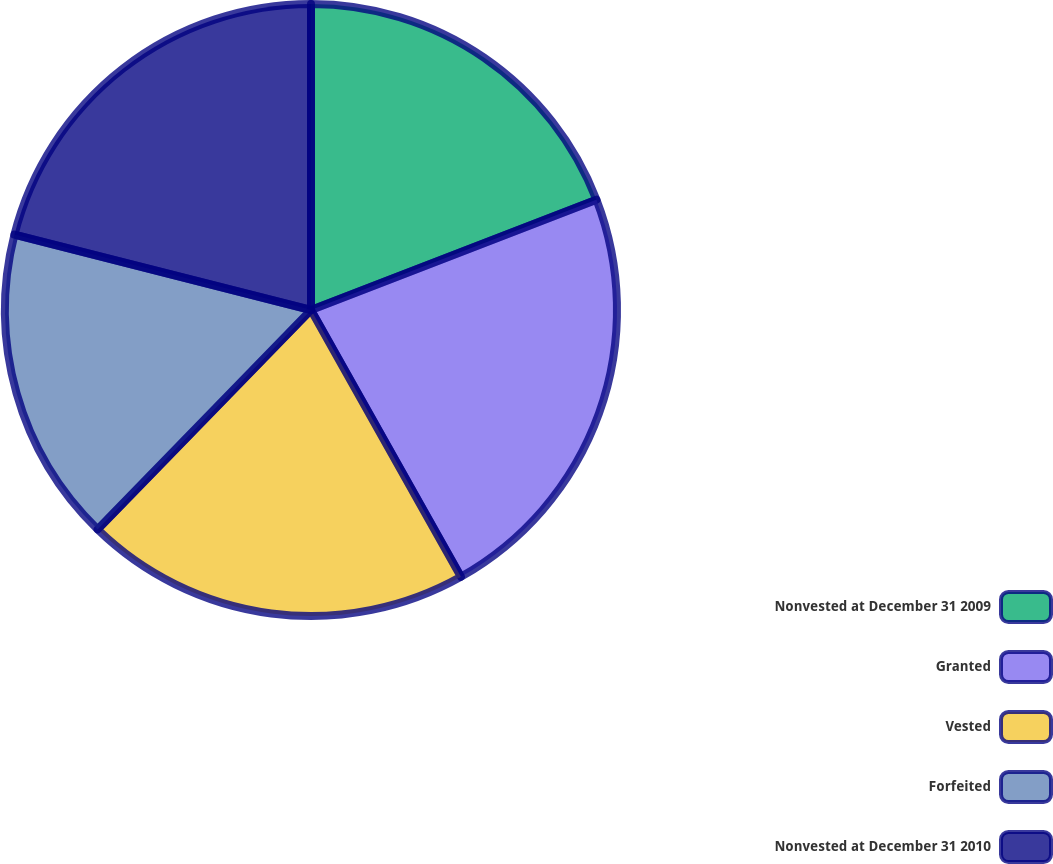Convert chart to OTSL. <chart><loc_0><loc_0><loc_500><loc_500><pie_chart><fcel>Nonvested at December 31 2009<fcel>Granted<fcel>Vested<fcel>Forfeited<fcel>Nonvested at December 31 2010<nl><fcel>19.13%<fcel>22.72%<fcel>20.43%<fcel>16.68%<fcel>21.04%<nl></chart> 